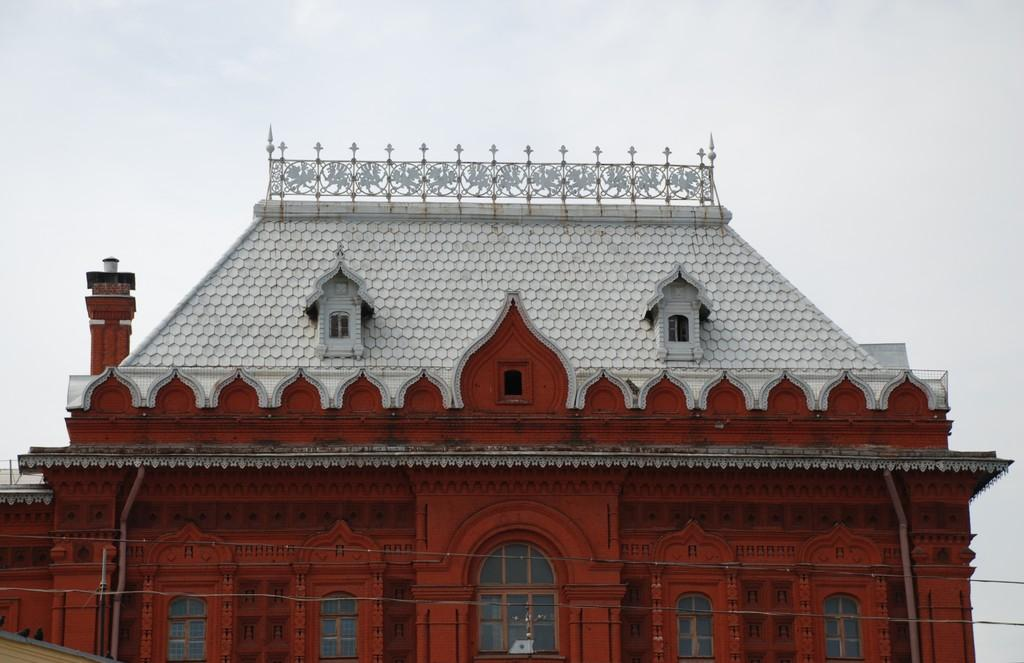What type of structure is in the image? There is a building in the image. What colors are used for the building? The building is white and red in color. What feature can be seen on the building? The building has windows. What else is visible in the image besides the building? There are wires visible in the image. What can be seen in the background of the image? The sky is visible in the background of the image. What type of toys can be seen on the committee in the image? There is no committee or toys present in the image; it features a building with windows and wires visible. What is the string used for in the image? There is no string present in the image. 